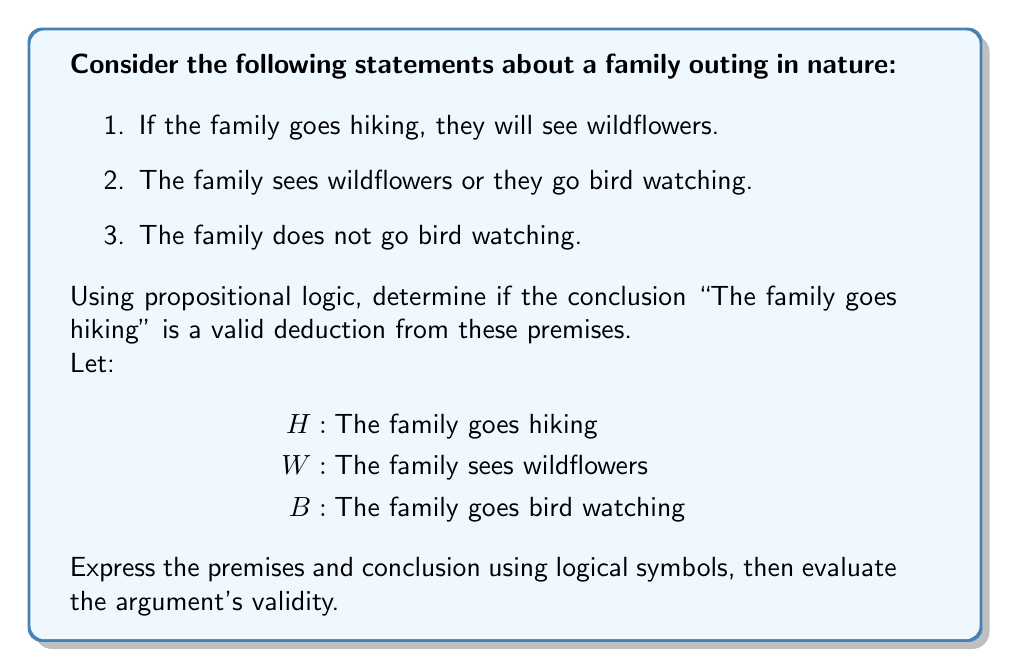Teach me how to tackle this problem. Let's approach this step-by-step:

1. First, we need to translate the given statements into logical symbols:

   Premise 1: $H \rightarrow W$ (If hiking, then wildflowers)
   Premise 2: $W \lor B$ (Wildflowers or bird watching)
   Premise 3: $\neg B$ (Not bird watching)
   Conclusion: $H$ (The family goes hiking)

2. Now, we can use the method of indirect proof. We'll assume the premises are true and the conclusion is false, then try to derive a contradiction.

3. Assume $\neg H$ (the negation of the conclusion)

4. From Premise 1 and the assumption $\neg H$, we can deduce $\neg W$ using modus tollens:
   $$(H \rightarrow W) \land \neg H \Rightarrow \neg W$$

5. From Premise 2 $(W \lor B)$ and the deduction $\neg W$, we can conclude $B$ using disjunctive syllogism:
   $$(W \lor B) \land \neg W \Rightarrow B$$

6. But this contradicts Premise 3 $(\neg B)$

7. Since we derived a contradiction from our assumption $\neg H$, we can conclude that $H$ must be true if all the premises are true.

Therefore, the argument is valid. If all the premises are true, the conclusion must also be true.
Answer: The conclusion "The family goes hiking" is a valid deduction from the given premises. 